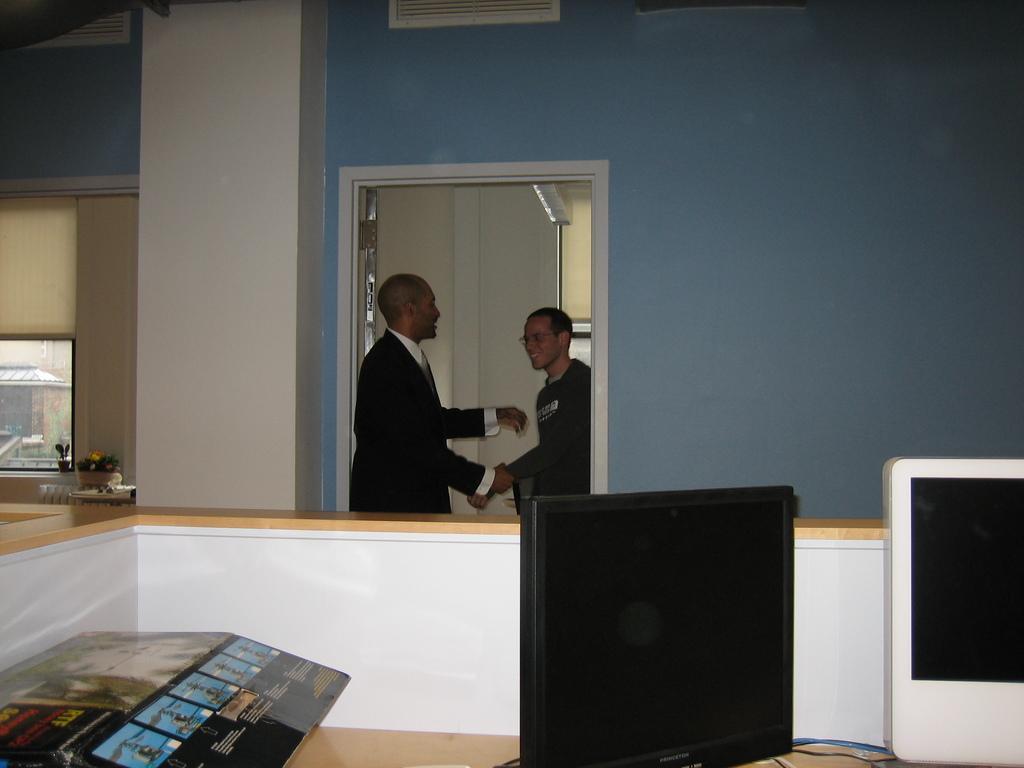Please provide a concise description of this image. In this image there are two persons standing and talking at the door. There is a computer on the table, at the left side of the image there is a houseplant at the window. 